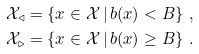Convert formula to latex. <formula><loc_0><loc_0><loc_500><loc_500>\mathcal { X } _ { \triangleleft } & = \{ x \in \mathcal { X } \, | \, b ( x ) < B \} \ , \\ \mathcal { X } _ { \triangleright } & = \{ x \in \mathcal { X } \, | \, b ( x ) \geq B \} \ .</formula> 